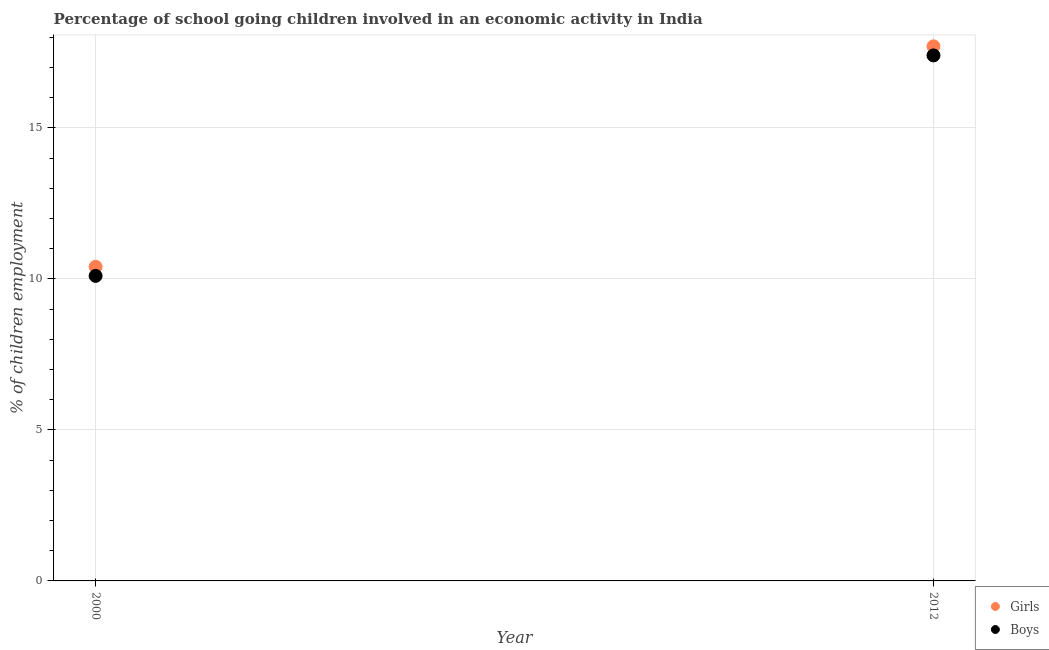Is the number of dotlines equal to the number of legend labels?
Ensure brevity in your answer.  Yes. Across all years, what is the maximum percentage of school going girls?
Make the answer very short. 17.7. Across all years, what is the minimum percentage of school going girls?
Provide a succinct answer. 10.4. In which year was the percentage of school going boys maximum?
Ensure brevity in your answer.  2012. In which year was the percentage of school going boys minimum?
Provide a short and direct response. 2000. What is the total percentage of school going girls in the graph?
Make the answer very short. 28.1. What is the difference between the percentage of school going boys in 2000 and that in 2012?
Provide a succinct answer. -7.3. What is the difference between the percentage of school going boys in 2012 and the percentage of school going girls in 2000?
Give a very brief answer. 7. What is the average percentage of school going boys per year?
Your answer should be very brief. 13.75. In the year 2012, what is the difference between the percentage of school going boys and percentage of school going girls?
Provide a succinct answer. -0.3. What is the ratio of the percentage of school going boys in 2000 to that in 2012?
Offer a very short reply. 0.58. What is the difference between two consecutive major ticks on the Y-axis?
Your response must be concise. 5. Are the values on the major ticks of Y-axis written in scientific E-notation?
Offer a terse response. No. Does the graph contain any zero values?
Provide a short and direct response. No. Where does the legend appear in the graph?
Your answer should be compact. Bottom right. How are the legend labels stacked?
Your answer should be compact. Vertical. What is the title of the graph?
Offer a terse response. Percentage of school going children involved in an economic activity in India. Does "RDB nonconcessional" appear as one of the legend labels in the graph?
Your answer should be very brief. No. What is the label or title of the Y-axis?
Keep it short and to the point. % of children employment. Across all years, what is the maximum % of children employment of Girls?
Give a very brief answer. 17.7. Across all years, what is the maximum % of children employment in Boys?
Ensure brevity in your answer.  17.4. What is the total % of children employment in Girls in the graph?
Offer a terse response. 28.1. What is the total % of children employment in Boys in the graph?
Your response must be concise. 27.5. What is the difference between the % of children employment in Boys in 2000 and that in 2012?
Offer a terse response. -7.3. What is the average % of children employment of Girls per year?
Offer a terse response. 14.05. What is the average % of children employment in Boys per year?
Provide a short and direct response. 13.75. In the year 2000, what is the difference between the % of children employment in Girls and % of children employment in Boys?
Your answer should be very brief. 0.3. In the year 2012, what is the difference between the % of children employment of Girls and % of children employment of Boys?
Your answer should be compact. 0.3. What is the ratio of the % of children employment in Girls in 2000 to that in 2012?
Make the answer very short. 0.59. What is the ratio of the % of children employment in Boys in 2000 to that in 2012?
Your response must be concise. 0.58. What is the difference between the highest and the second highest % of children employment in Boys?
Offer a very short reply. 7.3. 